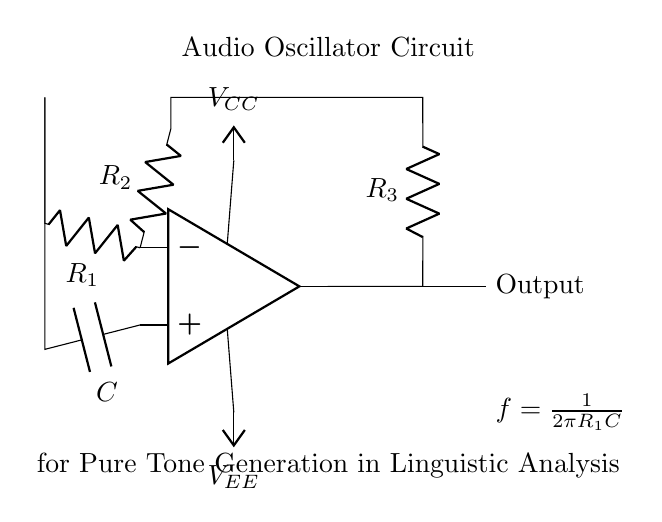What type of circuit is shown? This circuit is an audio oscillator, which is identified by the operational amplifier configuration and components designed to produce oscillating signals.
Answer: Audio oscillator What is the role of the capacitor in this circuit? The capacitor is used to store and release charge, contributing to the timing characteristics of the oscillator, specifically determining the frequency along with the resistors.
Answer: Timing component What is the output of the circuit? The output is the pure tone signal generated by the oscillations of the circuit, indicated by the "Output" label near terminal output.
Answer: Pure tone signal What determines the frequency of oscillation? The frequency is determined by the formula involving resistor one and capacitance: f equals one over two pi R1 C, referring to the specific values of R1 and C in the circuit.
Answer: R1 and C What is the value of Vcc in the circuit? The circuit doesn’t specify actual values, but it indicates a power supply labeled Vcc to provide the positive voltage. Generally, it is a set positive voltage used by the op-amp.
Answer: Positive voltage How does this circuit generate a pure tone? The oscillator circuit generates a pure tone through positive feedback and oscillatory behavior of the op-amp, creating a sinusoidal output signal at a particular frequency defined by its components.
Answer: Through feedback and oscillation Which components are used to control the oscillation frequency? The oscillation frequency is controlled by resistor R1 and capacitor C, connected in the feedback loop of the op-amp, directly influencing the timing of the oscillations.
Answer: R1 and C 